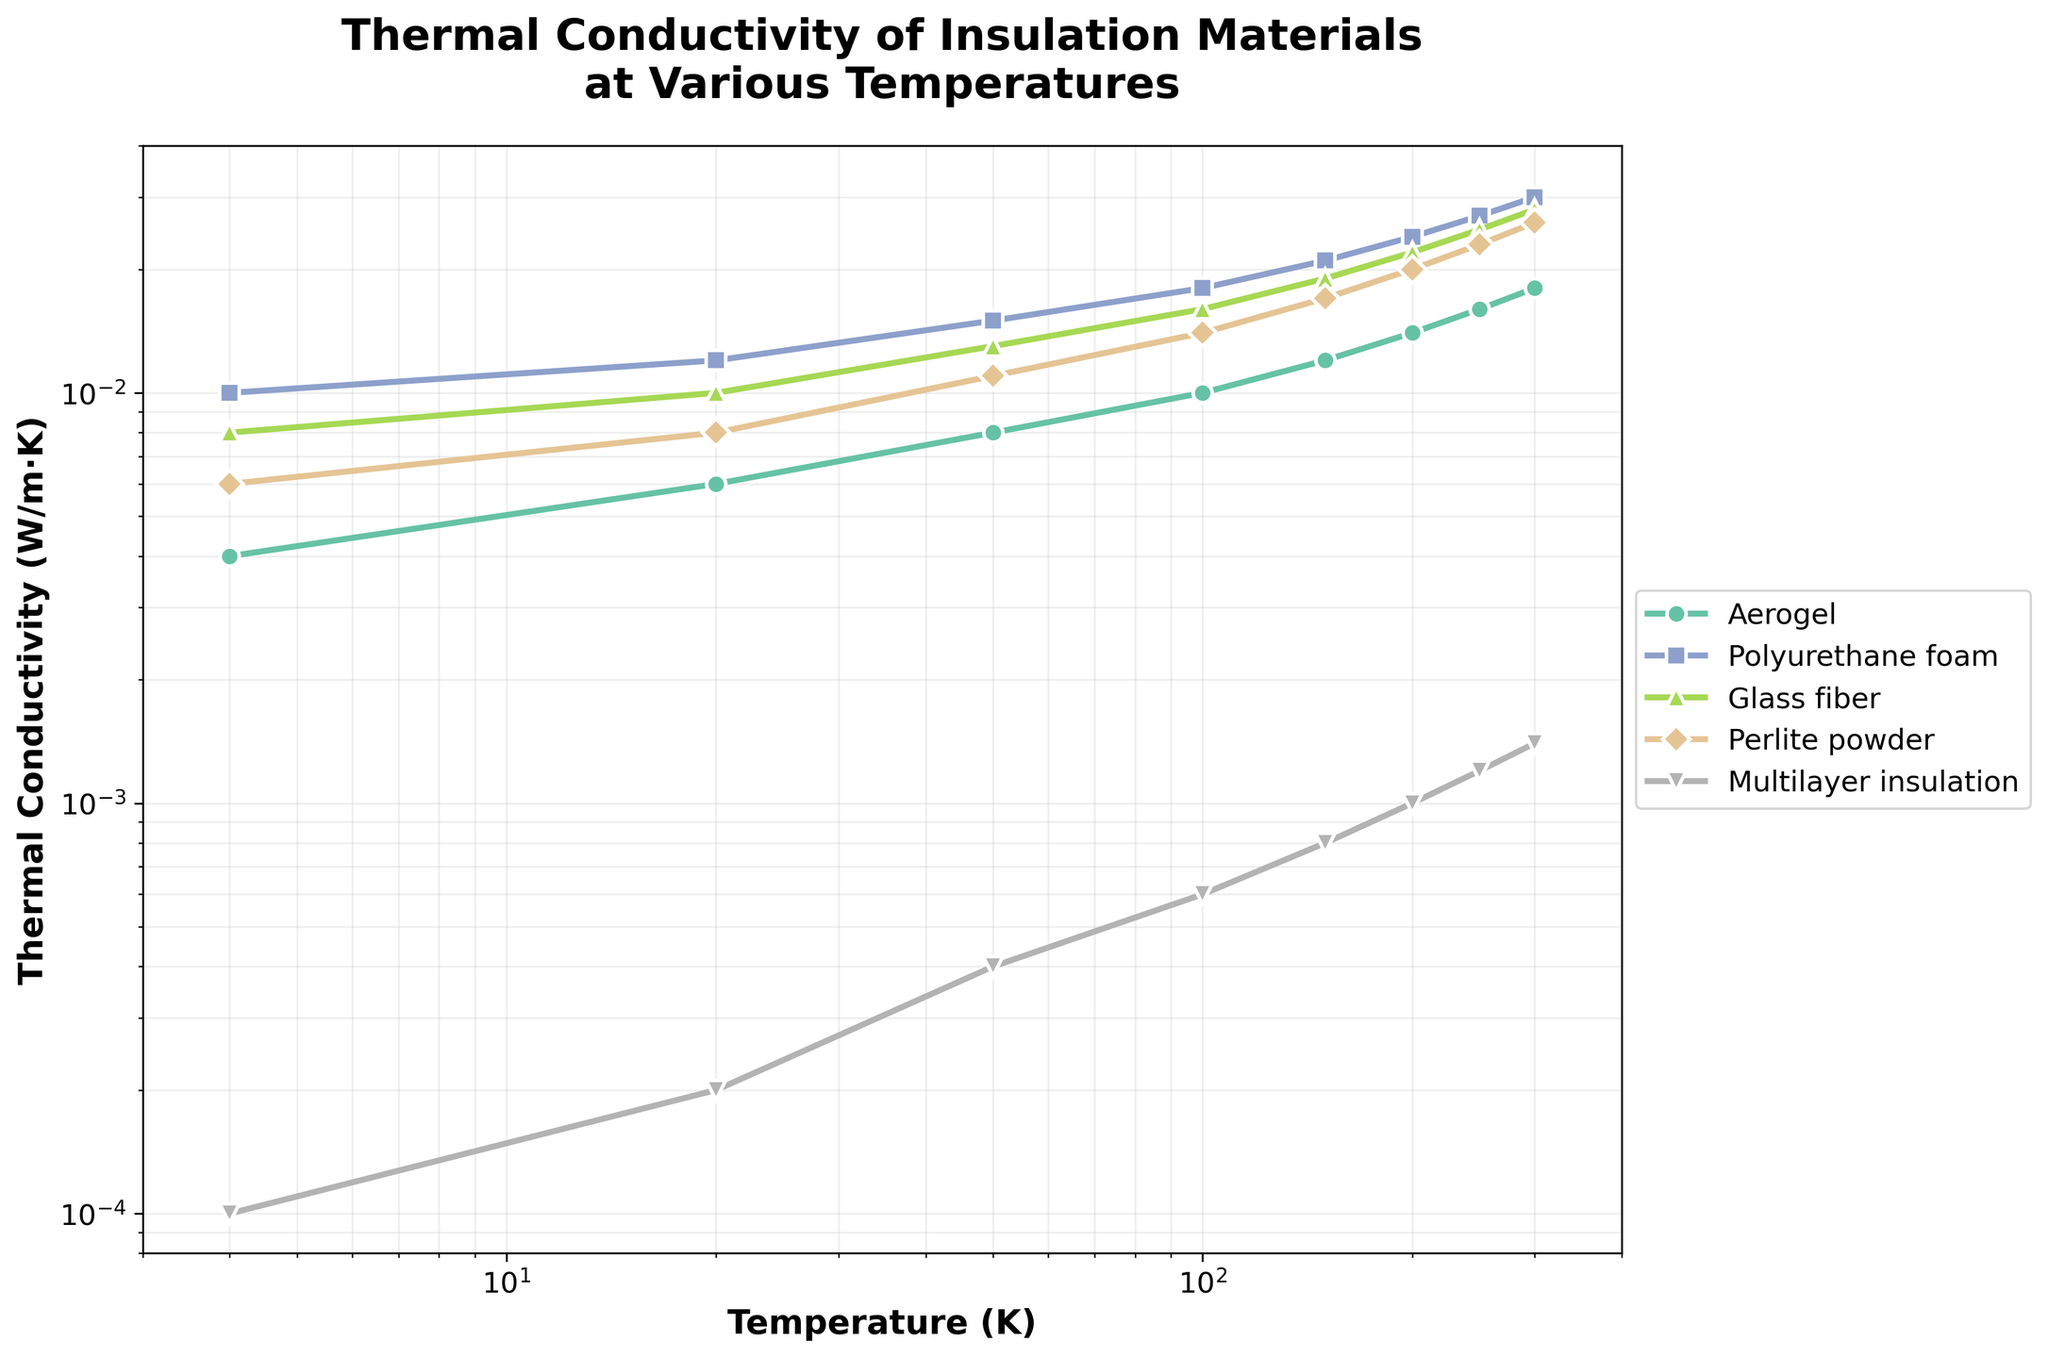Which material has the lowest thermal conductivity at 4K? From the chart, the material with the lowest thermal conductivity at 4K can be seen visually. Multilayer insulation has the lowest line and also the smallest data point at the start.
Answer: Multilayer insulation How does the thermal conductivity of Aerogel compare to Polyurethane foam at 150K? Comparing the heights of the lines for Aerogel and Polyurethane foam at 150K, Aerogel's line is lower. Aerogel has a lower thermal conductivity (0.012 W/m·K) compared to Polyurethane foam (0.021 W/m·K) at 150K.
Answer: Aerogel is lower Which material shows the highest increase in thermal conductivity as temperature rises from 4K to 300K? To find this, we look for the steepest slope from 4K to 300K. Polyurethane foam and Glass fiber both increase significantly, but Polyurethane foam shows a slightly steeper rise in visual terms.
Answer: Polyurethane foam Is there any material that has a nearly constant thermal conductivity across the temperature range? We need to look for a line that is relatively flat across 4K to 300K. No material is entirely flat, but Multilayer insulation has the least change, showing a near-constant thermal conductivity.
Answer: Multilayer insulation What's the average thermal conductivity of Glass fiber at 100K and 200K? Look at the values: 100K (0.016 W/m·K) and 200K (0.022 W/m·K). The average is (0.016 + 0.022) / 2 = 0.019.
Answer: 0.019 W/m·K Which material has consistently lower thermal conductivity than Polyurethane foam at all temperatures sampled? By comparing the positions of the line markers over all temperature points, Aerogel, Perlite powder, and Multilayer insulation all lie below Polyurethane foam.
Answer: Aerogel, Perlite powder, Multilayer insulation Of the materials shown, which one has the highest thermal conductivity at 20K? Inspecting the plot at 20K visually, Polyurethane foam has the highest mark on the y-axis.
Answer: Polyurethane foam 